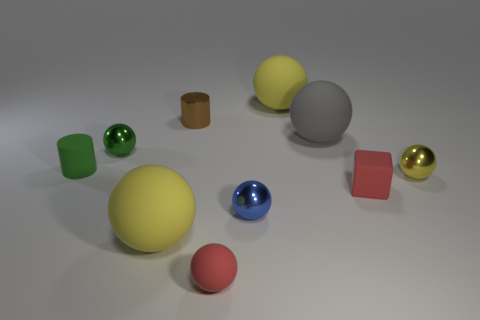Is there a small matte ball of the same color as the small rubber cube?
Your answer should be compact. Yes. There is a yellow matte thing in front of the shiny cylinder; does it have the same size as the tiny brown metallic object?
Provide a short and direct response. No. Is there any other thing of the same color as the matte cylinder?
Provide a succinct answer. Yes. What shape is the green rubber thing?
Ensure brevity in your answer.  Cylinder. How many yellow balls are left of the red block and to the right of the shiny cylinder?
Provide a short and direct response. 1. Is the color of the cube the same as the small rubber cylinder?
Provide a short and direct response. No. There is a small red object that is the same shape as the blue thing; what material is it?
Provide a succinct answer. Rubber. Is there anything else that is the same material as the small brown object?
Your answer should be compact. Yes. Are there an equal number of brown shiny things that are in front of the red matte ball and green things left of the small green cylinder?
Ensure brevity in your answer.  Yes. Is the material of the blue ball the same as the gray ball?
Your answer should be compact. No. 